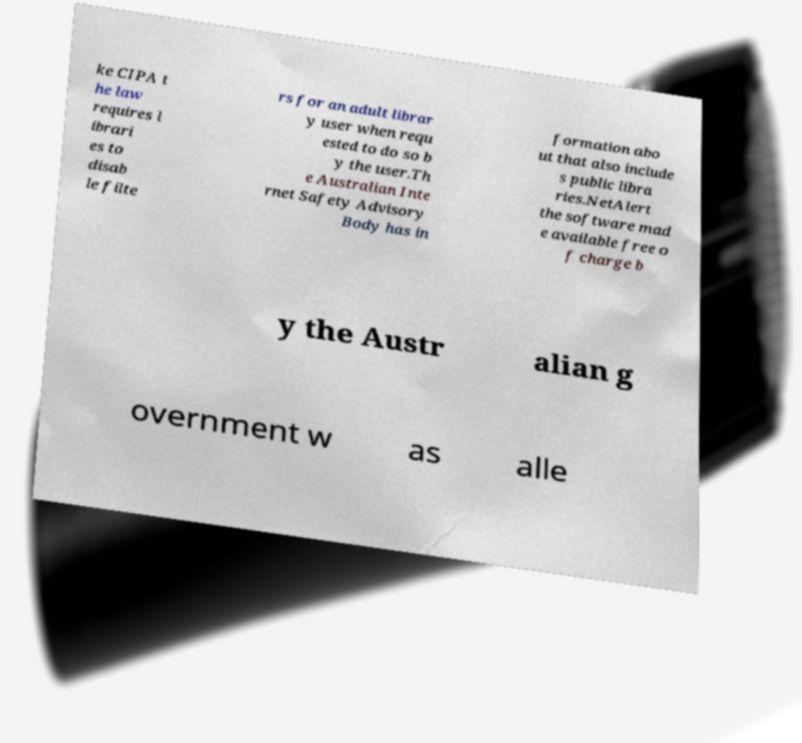For documentation purposes, I need the text within this image transcribed. Could you provide that? ke CIPA t he law requires l ibrari es to disab le filte rs for an adult librar y user when requ ested to do so b y the user.Th e Australian Inte rnet Safety Advisory Body has in formation abo ut that also include s public libra ries.NetAlert the software mad e available free o f charge b y the Austr alian g overnment w as alle 